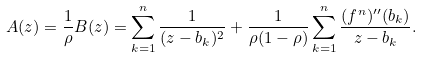Convert formula to latex. <formula><loc_0><loc_0><loc_500><loc_500>A ( z ) = \frac { 1 } { \rho } B ( z ) = \sum _ { k = 1 } ^ { n } \frac { 1 } { ( z - b _ { k } ) ^ { 2 } } + \frac { 1 } { \rho ( 1 - \rho ) } \sum _ { k = 1 } ^ { n } \frac { ( f ^ { n } ) ^ { \prime \prime } ( b _ { k } ) } { z - b _ { k } } .</formula> 